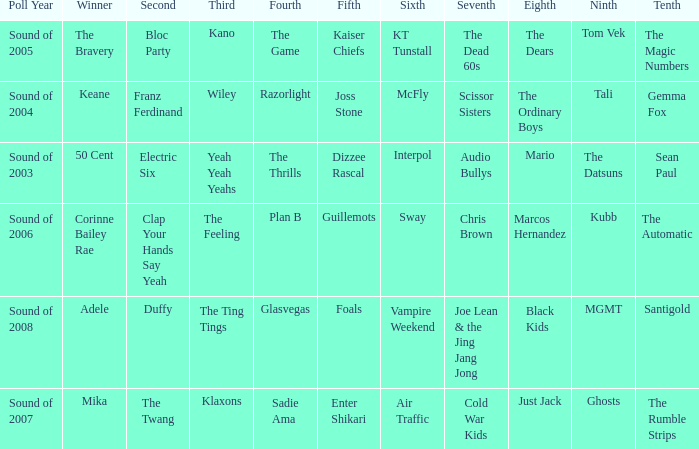When Interpol is in 6th, who is in 7th? 1.0. 